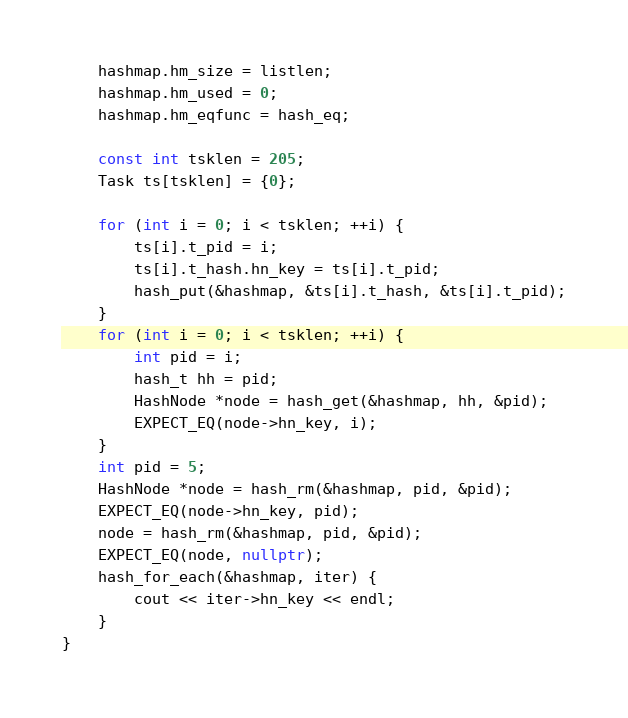<code> <loc_0><loc_0><loc_500><loc_500><_C++_>    hashmap.hm_size = listlen;
    hashmap.hm_used = 0;
    hashmap.hm_eqfunc = hash_eq;

    const int tsklen = 205;
    Task ts[tsklen] = {0};

    for (int i = 0; i < tsklen; ++i) {
        ts[i].t_pid = i;
        ts[i].t_hash.hn_key = ts[i].t_pid;
        hash_put(&hashmap, &ts[i].t_hash, &ts[i].t_pid);
    }
    for (int i = 0; i < tsklen; ++i) {
        int pid = i;
        hash_t hh = pid;
        HashNode *node = hash_get(&hashmap, hh, &pid);
        EXPECT_EQ(node->hn_key, i);
    }
    int pid = 5;
    HashNode *node = hash_rm(&hashmap, pid, &pid);
    EXPECT_EQ(node->hn_key, pid);
    node = hash_rm(&hashmap, pid, &pid);
    EXPECT_EQ(node, nullptr);
    hash_for_each(&hashmap, iter) {
        cout << iter->hn_key << endl;
    }
}
</code> 